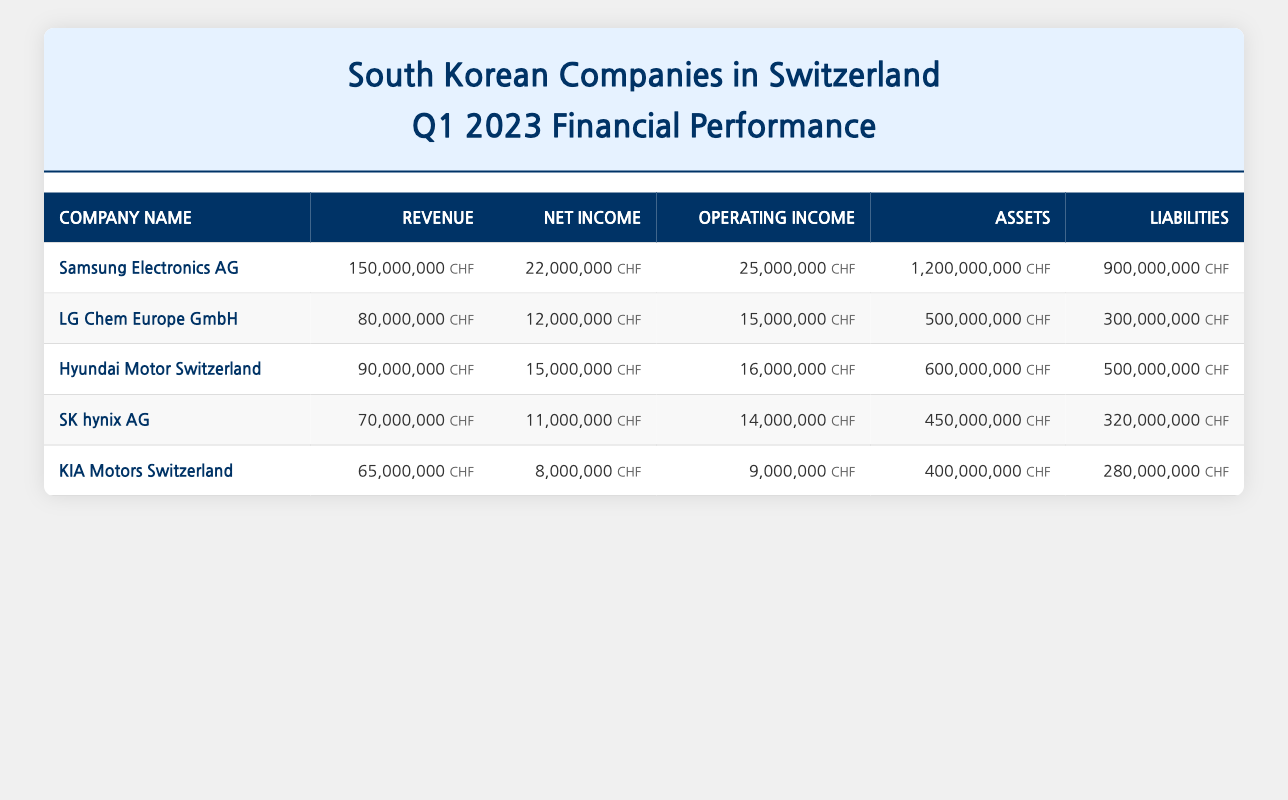What is the total revenue of all companies listed in Q1 2023? To find the total revenue, we sum up the revenue of each company: Samsung Electronics AG (150000000) + LG Chem Europe GmbH (80000000) + Hyundai Motor Switzerland (90000000) + SK hynix AG (70000000) + KIA Motors Switzerland (65000000) = 150000000 + 80000000 + 90000000 + 70000000 + 65000000 = 415000000.
Answer: 415000000 Which company reported the highest net income in Q1 2023? By looking at the net income of each company, we can see that Samsung Electronics AG has the highest net income at 22000000.
Answer: Samsung Electronics AG Is the total liabilities more than total assets for LG Chem Europe GmbH? For LG Chem Europe GmbH, the liabilities are 300000000 and the assets are 500000000. Since 300000000 is less than 500000000, the statement is false.
Answer: No What is the operating income difference between Samsung Electronics AG and Hyundai Motor Switzerland? Samsung Electronics AG has an operating income of 25000000, while Hyundai Motor Switzerland has an operating income of 16000000. The difference is 25000000 - 16000000 = 9000000.
Answer: 9000000 What percentage of total assets does SK hynix AG represent among all companies? The total assets are 1200000000 + 500000000 + 600000000 + 450000000 + 400000000 = 3200000000. SK hynix AG has assets worth 450000000. The percentage is (450000000 / 3200000000) * 100 = 14.06%.
Answer: 14.06% How many companies have a revenue greater than 70000000? Looking at the revenue column, we find that Samsung Electronics AG, LG Chem Europe GmbH, Hyundai Motor Switzerland, and SK hynix AG have revenue greater than 70000000. That's a total of 4 companies.
Answer: 4 Is KIA Motors Switzerland’s net income less than that of SK hynix AG? KIA Motors Switzerland has a net income of 8000000, and SK hynix AG has a net income of 11000000. Since 8000000 is less than 11000000, the statement is true.
Answer: Yes What is the average operating income of the companies listed in Q1 2023? To calculate the average operating income, we sum the operating incomes (25000000 + 15000000 + 16000000 + 14000000 + 9000000 = 84000000) and divide by the number of companies (5). The average is 84000000 / 5 = 16800000.
Answer: 16800000 Which company has the lowest total assets reported in Q1 2023? By examining the assets, we see that KIA Motors Switzerland has the lowest assets at 400000000.
Answer: KIA Motors Switzerland 